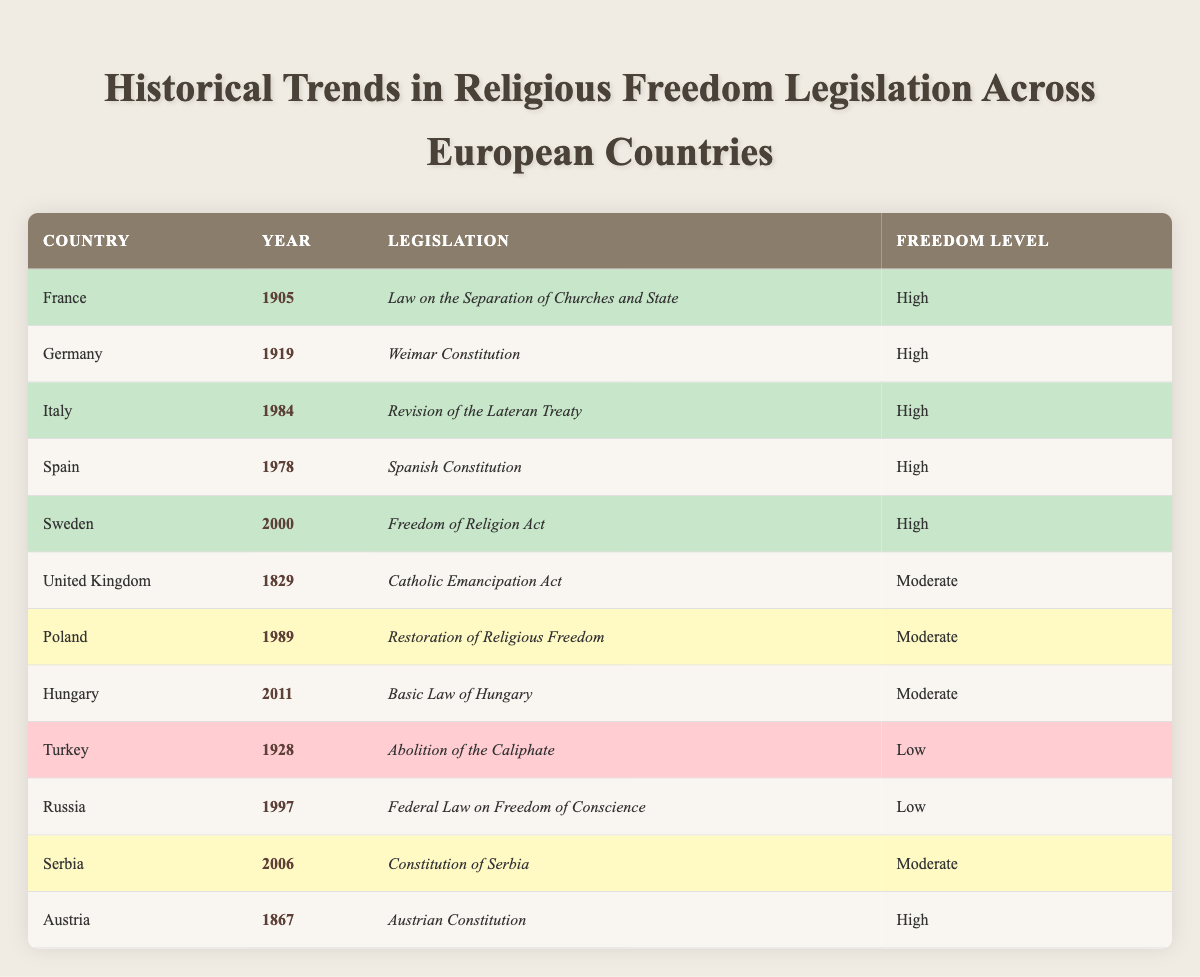What is the legislation enacted in France in 1905? The table lists "Law on the Separation of Churches and State" as the legislation for France in the year 1905.
Answer: Law on the Separation of Churches and State Which countries have a "High" level of religious freedom? By scanning the Freedom Level column, the countries classified with "High" freedom levels are France, Germany, Italy, Spain, Sweden, and Austria.
Answer: France, Germany, Italy, Spain, Sweden, Austria How many countries enacted laws related to religious freedom in the 20th century? The following countries enacted laws in the 20th century: France (1905), Germany (1919), Turkey (1928), Italy (1984), Spain (1978), Poland (1989), Serbia (2006), and Sweden (2000). This totals to 8 countries.
Answer: 8 Is it true that all laws enacted in the 21st century have a "High" level of religious freedom? Only one law in the table was enacted in the 21st century (Hungary in 2011) and it has a "Moderate" freedom level. Therefore, the statement is false.
Answer: False What is the difference in the freedom level between the earliest and latest legislation in the table? The earliest legislation is from the United Kingdom in 1829 with a "Moderate" level, and the latest is from Hungary in 2011 with a "Moderate" level as well. Therefore, there is no difference in the freedom level.
Answer: 0 Which country has the legislation titled "Catholic Emancipation Act" and what is its freedom level? The "Catholic Emancipation Act" was enacted in the United Kingdom in 1829, and its freedom level is "Moderate."
Answer: United Kingdom; Moderate Count the total number of laws that have been categorized as "Low" freedom levels. According to the table, Turkey (1928) and Russia (1997) are the only two countries with laws categorized as "Low," thus totaling 2 laws.
Answer: 2 In how many different years were "High" level laws enacted? By analyzing the table, "High" level laws were enacted in the years 1905 (France), 1919 (Germany), 1984 (Italy), 1978 (Spain), 2000 (Sweden), and 1867 (Austria), which totals to 6 unique years.
Answer: 6 